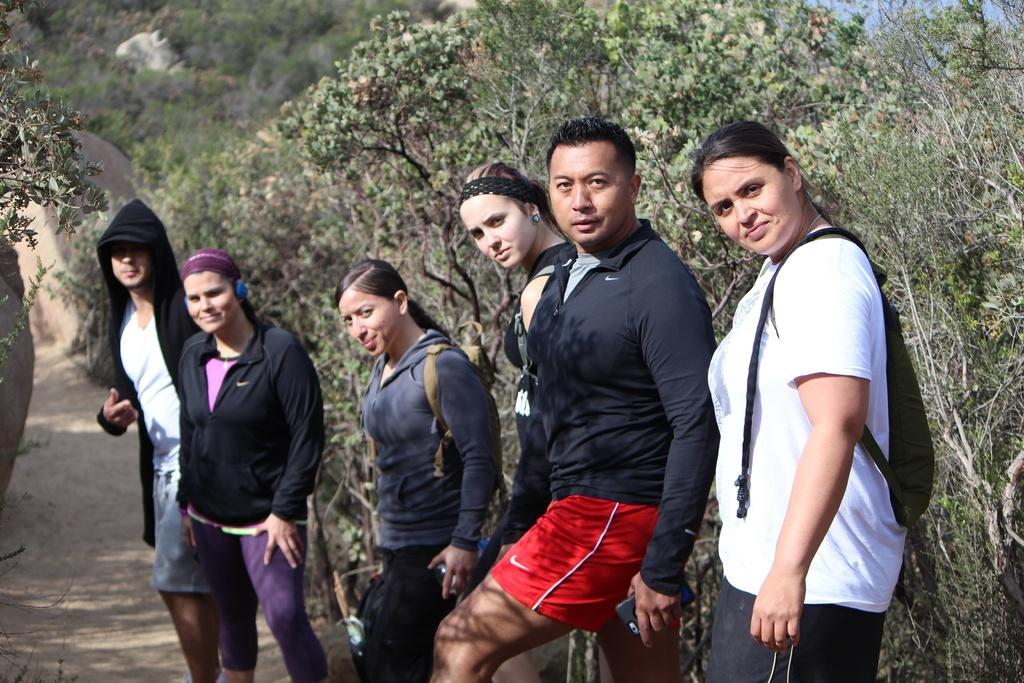How many people are in the image? There are people in the image, but the exact number is not specified. What are the people wearing in the image? The people are wearing coats in the image. What else are some of the people carrying in the image? Some people are wearing bags in the image. What are the people holding in the image? The people are holding objects in the image. What can be seen in the background of the image? There are trees and rocks in the background of the image. What is visible at the bottom of the image? There is ground visible at the bottom of the image. What type of circle is being drawn by the people in the image? There is no circle being drawn by the people in the image. What type of glove is being worn by the people in the image? There is no mention of gloves being worn by the people in the image. 